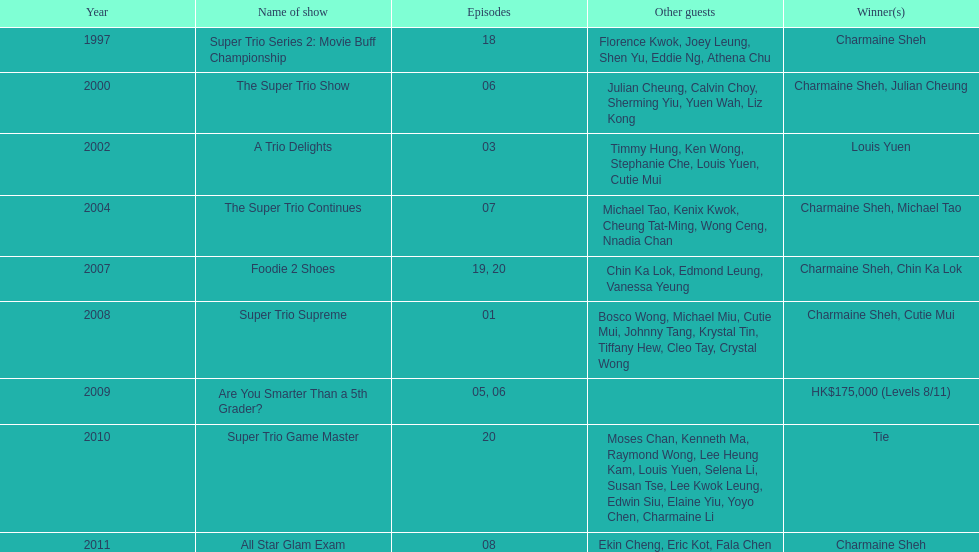In the 2002 show "a trio delights," what was the count of other attendees? 5. 